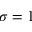<formula> <loc_0><loc_0><loc_500><loc_500>\sigma = 1</formula> 